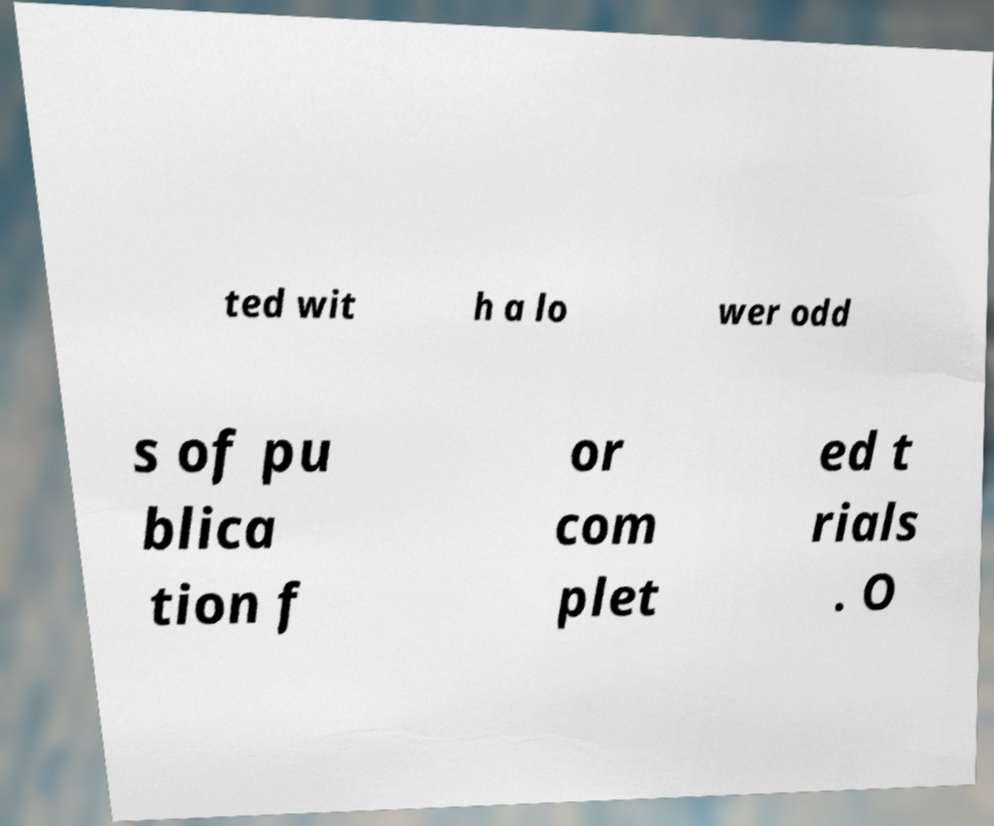What messages or text are displayed in this image? I need them in a readable, typed format. ted wit h a lo wer odd s of pu blica tion f or com plet ed t rials . O 